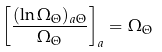Convert formula to latex. <formula><loc_0><loc_0><loc_500><loc_500>\left [ \frac { ( \ln \Omega _ { \Theta } ) _ { a \Theta } } { \Omega _ { \Theta } } \right ] _ { a } = \Omega _ { \Theta }</formula> 